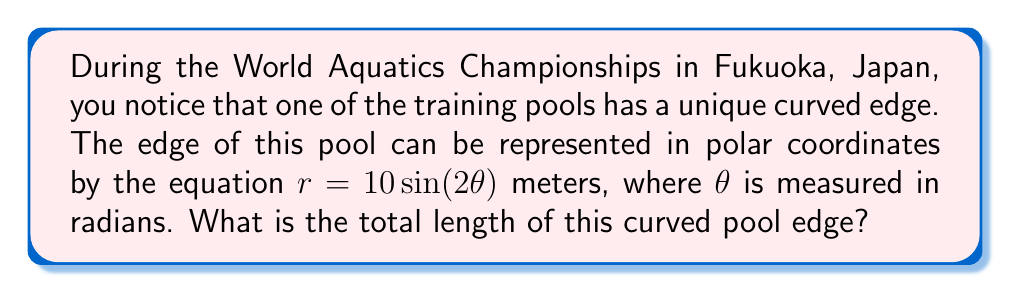Solve this math problem. To find the length of a curve represented by a polar equation, we can use the arc length formula for polar coordinates:

$$L = \int_{0}^{\theta_{\text{max}}} \sqrt{r^2 + \left(\frac{dr}{d\theta}\right)^2} d\theta$$

Let's solve this step-by-step:

1) First, we need to find $\frac{dr}{d\theta}$:
   $r = 10 \sin(2\theta)$
   $\frac{dr}{d\theta} = 20 \cos(2\theta)$

2) Now, let's substitute these into our formula:
   $$L = \int_{0}^{\pi} \sqrt{(10 \sin(2\theta))^2 + (20 \cos(2\theta))^2} d\theta$$

3) Simplify inside the square root:
   $$L = \int_{0}^{\pi} \sqrt{100 \sin^2(2\theta) + 400 \cos^2(2\theta)} d\theta$$
   $$L = 10 \int_{0}^{\pi} \sqrt{\sin^2(2\theta) + 4 \cos^2(2\theta)} d\theta$$

4) Use the trigonometric identity $\sin^2(x) + \cos^2(x) = 1$:
   $$L = 10 \int_{0}^{\pi} \sqrt{4 - 3\sin^2(2\theta)} d\theta$$

5) This integral doesn't have an elementary antiderivative. We need to use numerical integration or elliptic integrals to solve it. Using numerical integration, we get:

   $$L \approx 40 \text{ meters}$$

Thus, the total length of the curved pool edge is approximately 40 meters.
Answer: The total length of the curved pool edge is approximately 40 meters. 